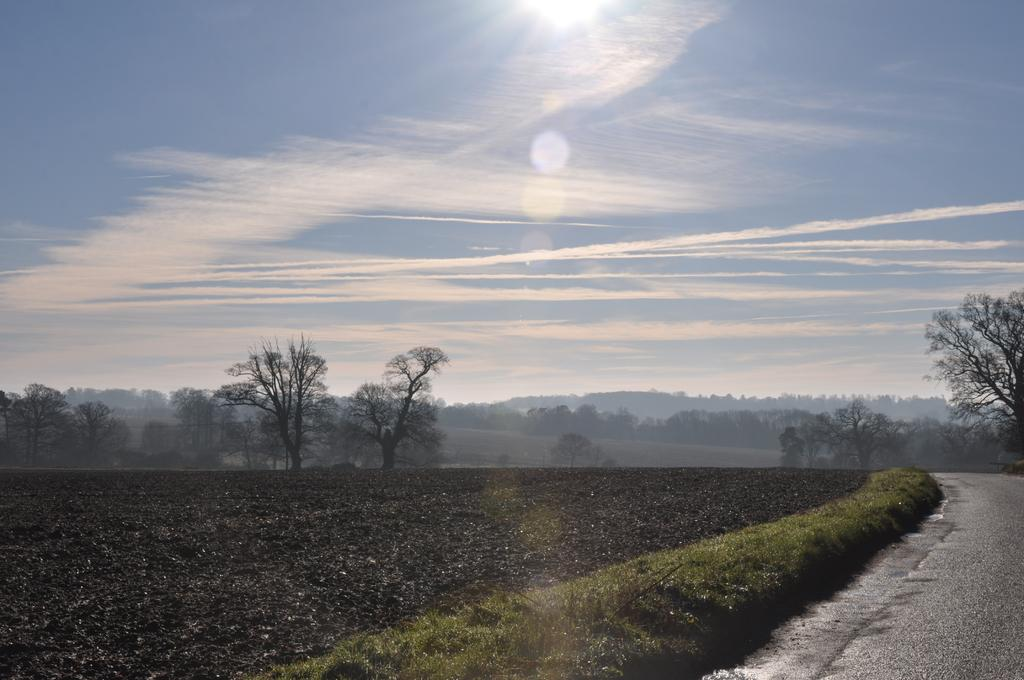What is located on the right side of the image? There is a road on the right side of the image. What can be seen in the background of the image? There are trees, hills, and the sky visible in the background of the image. Can you hear the fireman calling out to the donkey in the image? There is no fireman or donkey present in the image, and therefore no such interaction can be heard or observed. 